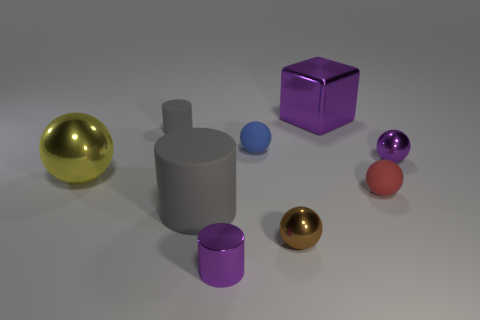If you had to categorize these objects, how would you group them? These objects could be categorized by shape: spheres, a cube, and cylinders. Alternatively, grouping by apparent material offers another criterion: metallic objects and non-metallic objects as two distinct categories. 